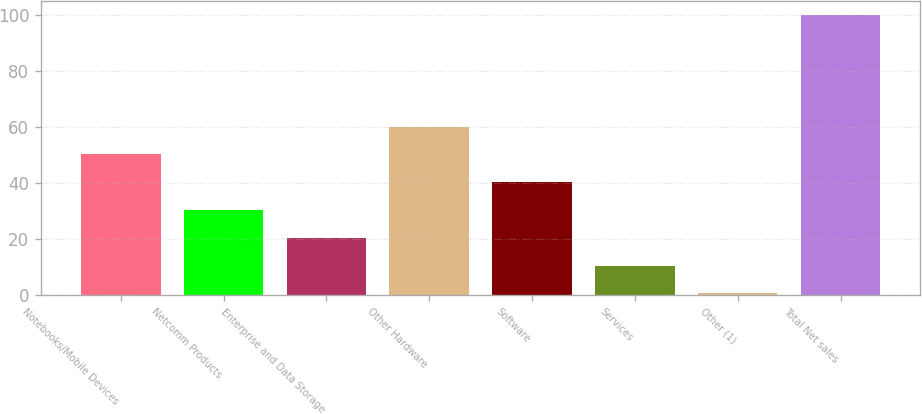<chart> <loc_0><loc_0><loc_500><loc_500><bar_chart><fcel>Notebooks/Mobile Devices<fcel>Netcomm Products<fcel>Enterprise and Data Storage<fcel>Other Hardware<fcel>Software<fcel>Services<fcel>Other (1)<fcel>Total Net sales<nl><fcel>50.25<fcel>30.35<fcel>20.4<fcel>60.2<fcel>40.3<fcel>10.45<fcel>0.5<fcel>100<nl></chart> 